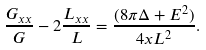<formula> <loc_0><loc_0><loc_500><loc_500>\frac { G _ { x x } } { G } - 2 \frac { L _ { x x } } { L } = \frac { ( 8 \pi \Delta + E ^ { 2 } ) } { 4 x L ^ { 2 } } .</formula> 